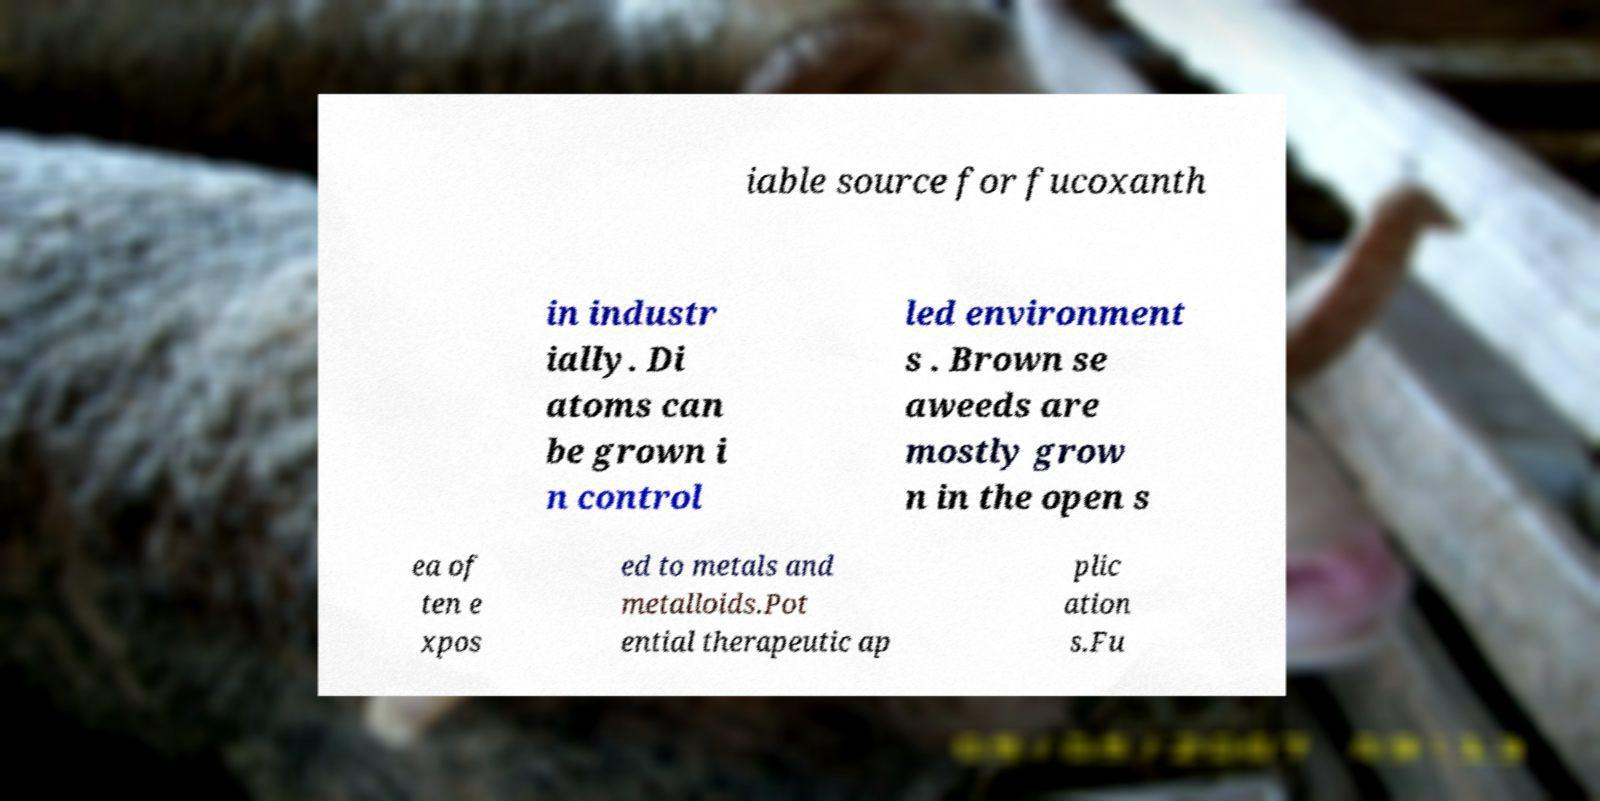Could you assist in decoding the text presented in this image and type it out clearly? iable source for fucoxanth in industr ially. Di atoms can be grown i n control led environment s . Brown se aweeds are mostly grow n in the open s ea of ten e xpos ed to metals and metalloids.Pot ential therapeutic ap plic ation s.Fu 